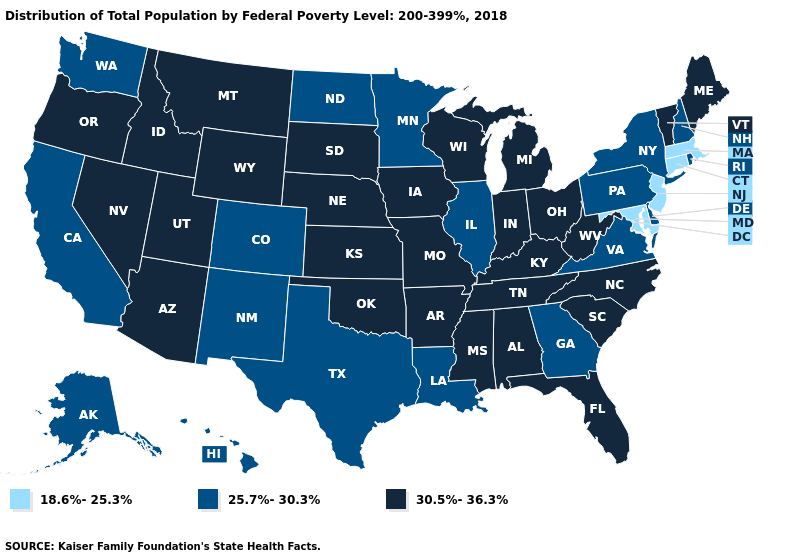What is the highest value in the USA?
Short answer required. 30.5%-36.3%. What is the value of Texas?
Quick response, please. 25.7%-30.3%. How many symbols are there in the legend?
Short answer required. 3. What is the value of North Carolina?
Write a very short answer. 30.5%-36.3%. Does the map have missing data?
Write a very short answer. No. Does California have the highest value in the West?
Be succinct. No. Name the states that have a value in the range 18.6%-25.3%?
Be succinct. Connecticut, Maryland, Massachusetts, New Jersey. What is the lowest value in the USA?
Quick response, please. 18.6%-25.3%. Which states have the lowest value in the USA?
Quick response, please. Connecticut, Maryland, Massachusetts, New Jersey. How many symbols are there in the legend?
Write a very short answer. 3. Does Oklahoma have the same value as Illinois?
Be succinct. No. Name the states that have a value in the range 30.5%-36.3%?
Concise answer only. Alabama, Arizona, Arkansas, Florida, Idaho, Indiana, Iowa, Kansas, Kentucky, Maine, Michigan, Mississippi, Missouri, Montana, Nebraska, Nevada, North Carolina, Ohio, Oklahoma, Oregon, South Carolina, South Dakota, Tennessee, Utah, Vermont, West Virginia, Wisconsin, Wyoming. What is the lowest value in the Northeast?
Give a very brief answer. 18.6%-25.3%. What is the value of New York?
Keep it brief. 25.7%-30.3%. 